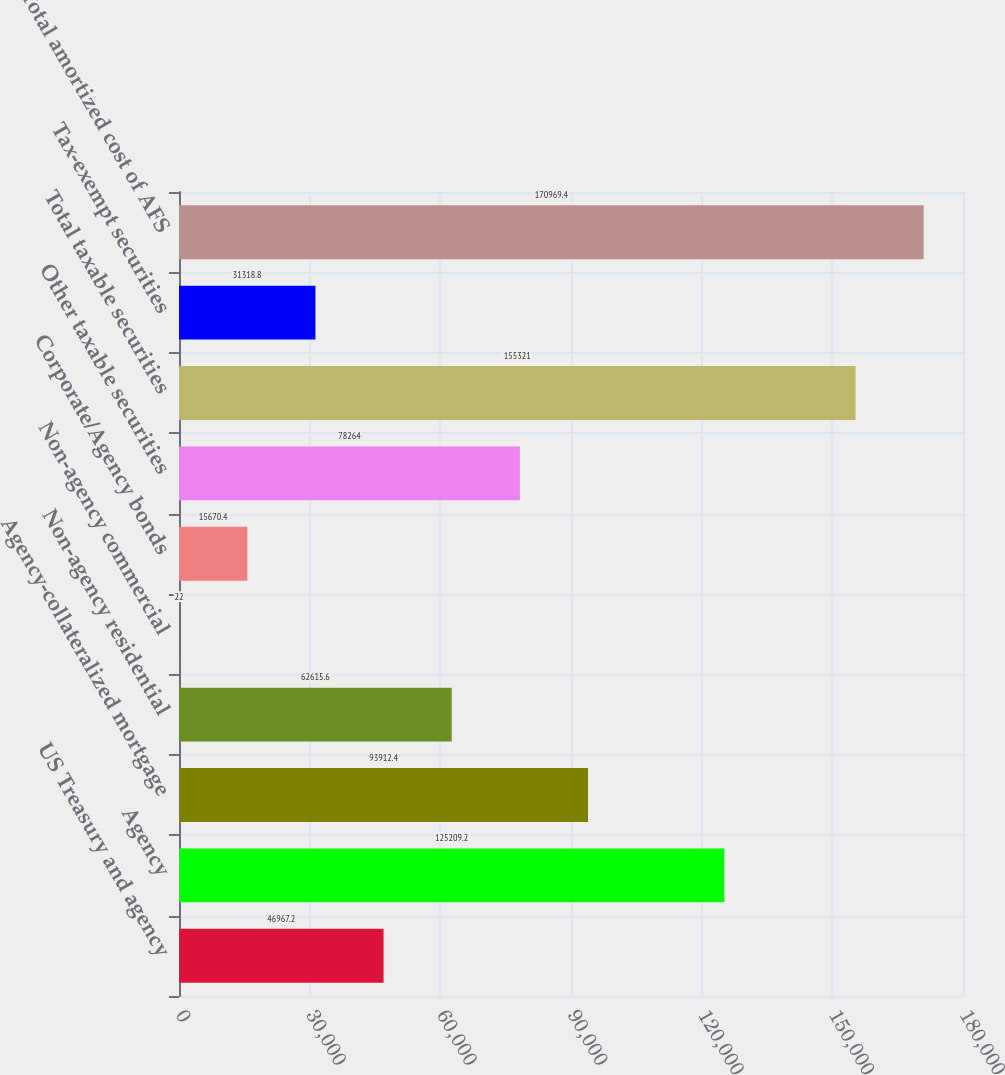Convert chart to OTSL. <chart><loc_0><loc_0><loc_500><loc_500><bar_chart><fcel>US Treasury and agency<fcel>Agency<fcel>Agency-collateralized mortgage<fcel>Non-agency residential<fcel>Non-agency commercial<fcel>Corporate/Agency bonds<fcel>Other taxable securities<fcel>Total taxable securities<fcel>Tax-exempt securities<fcel>Total amortized cost of AFS<nl><fcel>46967.2<fcel>125209<fcel>93912.4<fcel>62615.6<fcel>22<fcel>15670.4<fcel>78264<fcel>155321<fcel>31318.8<fcel>170969<nl></chart> 